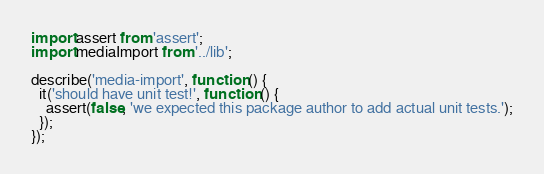<code> <loc_0><loc_0><loc_500><loc_500><_JavaScript_>import assert from 'assert';
import mediaImport from '../lib';

describe('media-import', function () {
  it('should have unit test!', function () {
    assert(false, 'we expected this package author to add actual unit tests.');
  });
});
</code> 